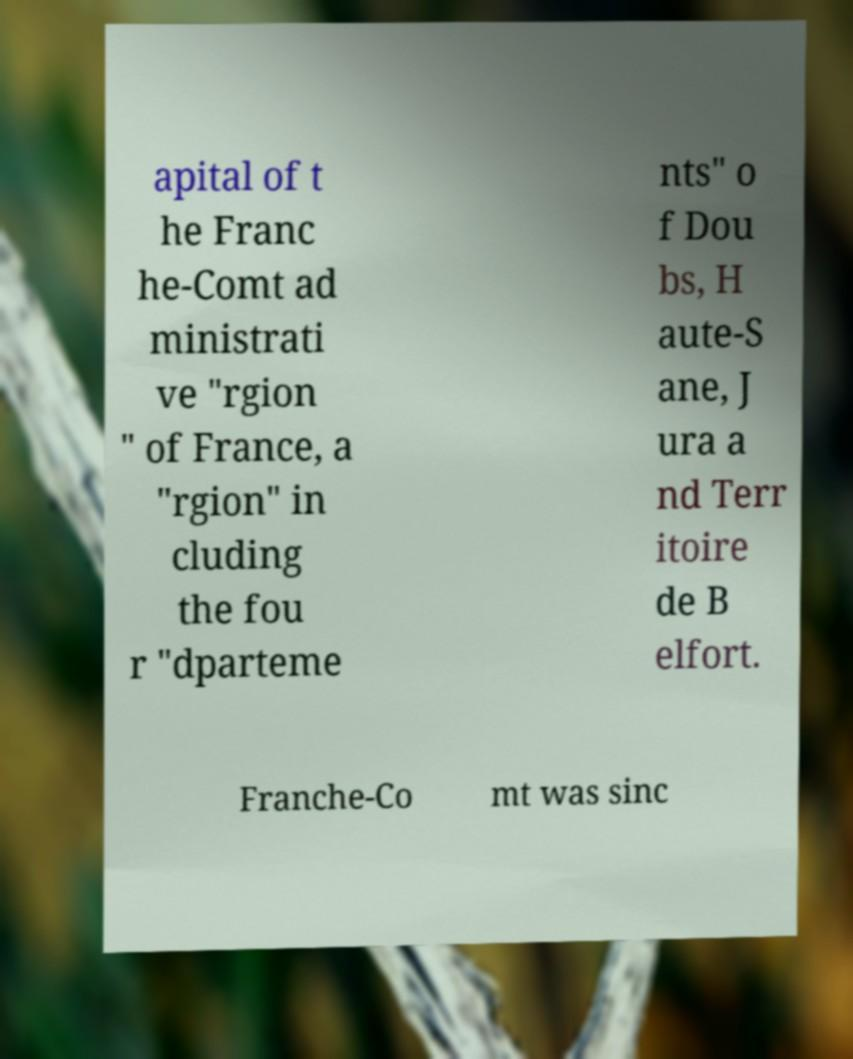Can you read and provide the text displayed in the image?This photo seems to have some interesting text. Can you extract and type it out for me? apital of t he Franc he-Comt ad ministrati ve "rgion " of France, a "rgion" in cluding the fou r "dparteme nts" o f Dou bs, H aute-S ane, J ura a nd Terr itoire de B elfort. Franche-Co mt was sinc 